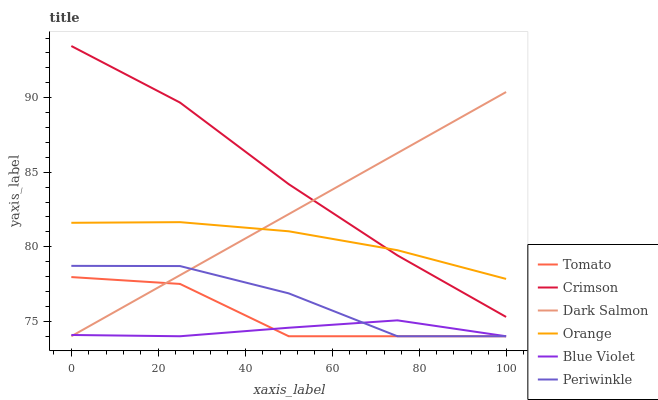Does Blue Violet have the minimum area under the curve?
Answer yes or no. Yes. Does Crimson have the maximum area under the curve?
Answer yes or no. Yes. Does Dark Salmon have the minimum area under the curve?
Answer yes or no. No. Does Dark Salmon have the maximum area under the curve?
Answer yes or no. No. Is Dark Salmon the smoothest?
Answer yes or no. Yes. Is Tomato the roughest?
Answer yes or no. Yes. Is Orange the smoothest?
Answer yes or no. No. Is Orange the roughest?
Answer yes or no. No. Does Tomato have the lowest value?
Answer yes or no. Yes. Does Orange have the lowest value?
Answer yes or no. No. Does Crimson have the highest value?
Answer yes or no. Yes. Does Dark Salmon have the highest value?
Answer yes or no. No. Is Periwinkle less than Crimson?
Answer yes or no. Yes. Is Orange greater than Tomato?
Answer yes or no. Yes. Does Dark Salmon intersect Crimson?
Answer yes or no. Yes. Is Dark Salmon less than Crimson?
Answer yes or no. No. Is Dark Salmon greater than Crimson?
Answer yes or no. No. Does Periwinkle intersect Crimson?
Answer yes or no. No. 